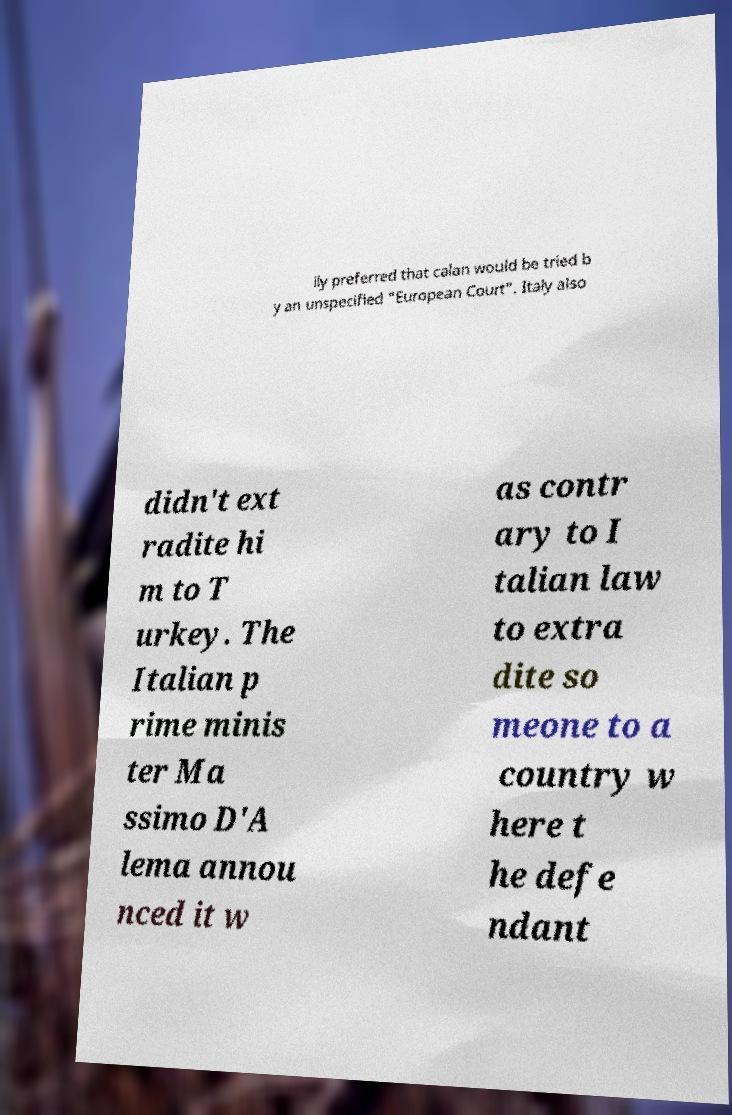Can you accurately transcribe the text from the provided image for me? ily preferred that calan would be tried b y an unspecified "European Court". Italy also didn't ext radite hi m to T urkey. The Italian p rime minis ter Ma ssimo D'A lema annou nced it w as contr ary to I talian law to extra dite so meone to a country w here t he defe ndant 